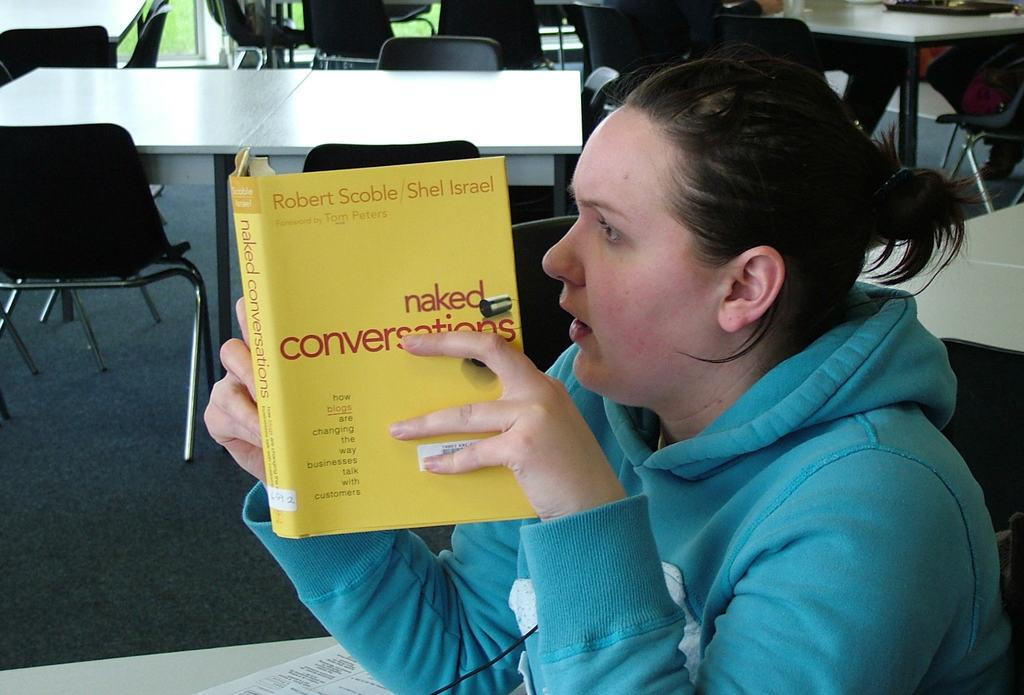Who is the main subject in the image? There is a woman in the image. What is the woman doing in the image? The woman is sitting on a chair and looking into a book. What is the woman holding in the image? The woman is holding the book. What else can be seen in the image besides the woman and the book? There are additional tables and chairs in the image. What type of yoke is the woman using to read the book in the image? There is no yoke present in the image; the woman is simply holding the book. What is the relation between the woman and the other people in the image? There is no indication of other people in the image, so it is impossible to determine any relationships. 